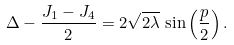<formula> <loc_0><loc_0><loc_500><loc_500>\Delta - \frac { J _ { 1 } - J _ { 4 } } { 2 } = 2 \sqrt { 2 \lambda } \, \sin \left ( \frac { p } { 2 } \right ) .</formula> 